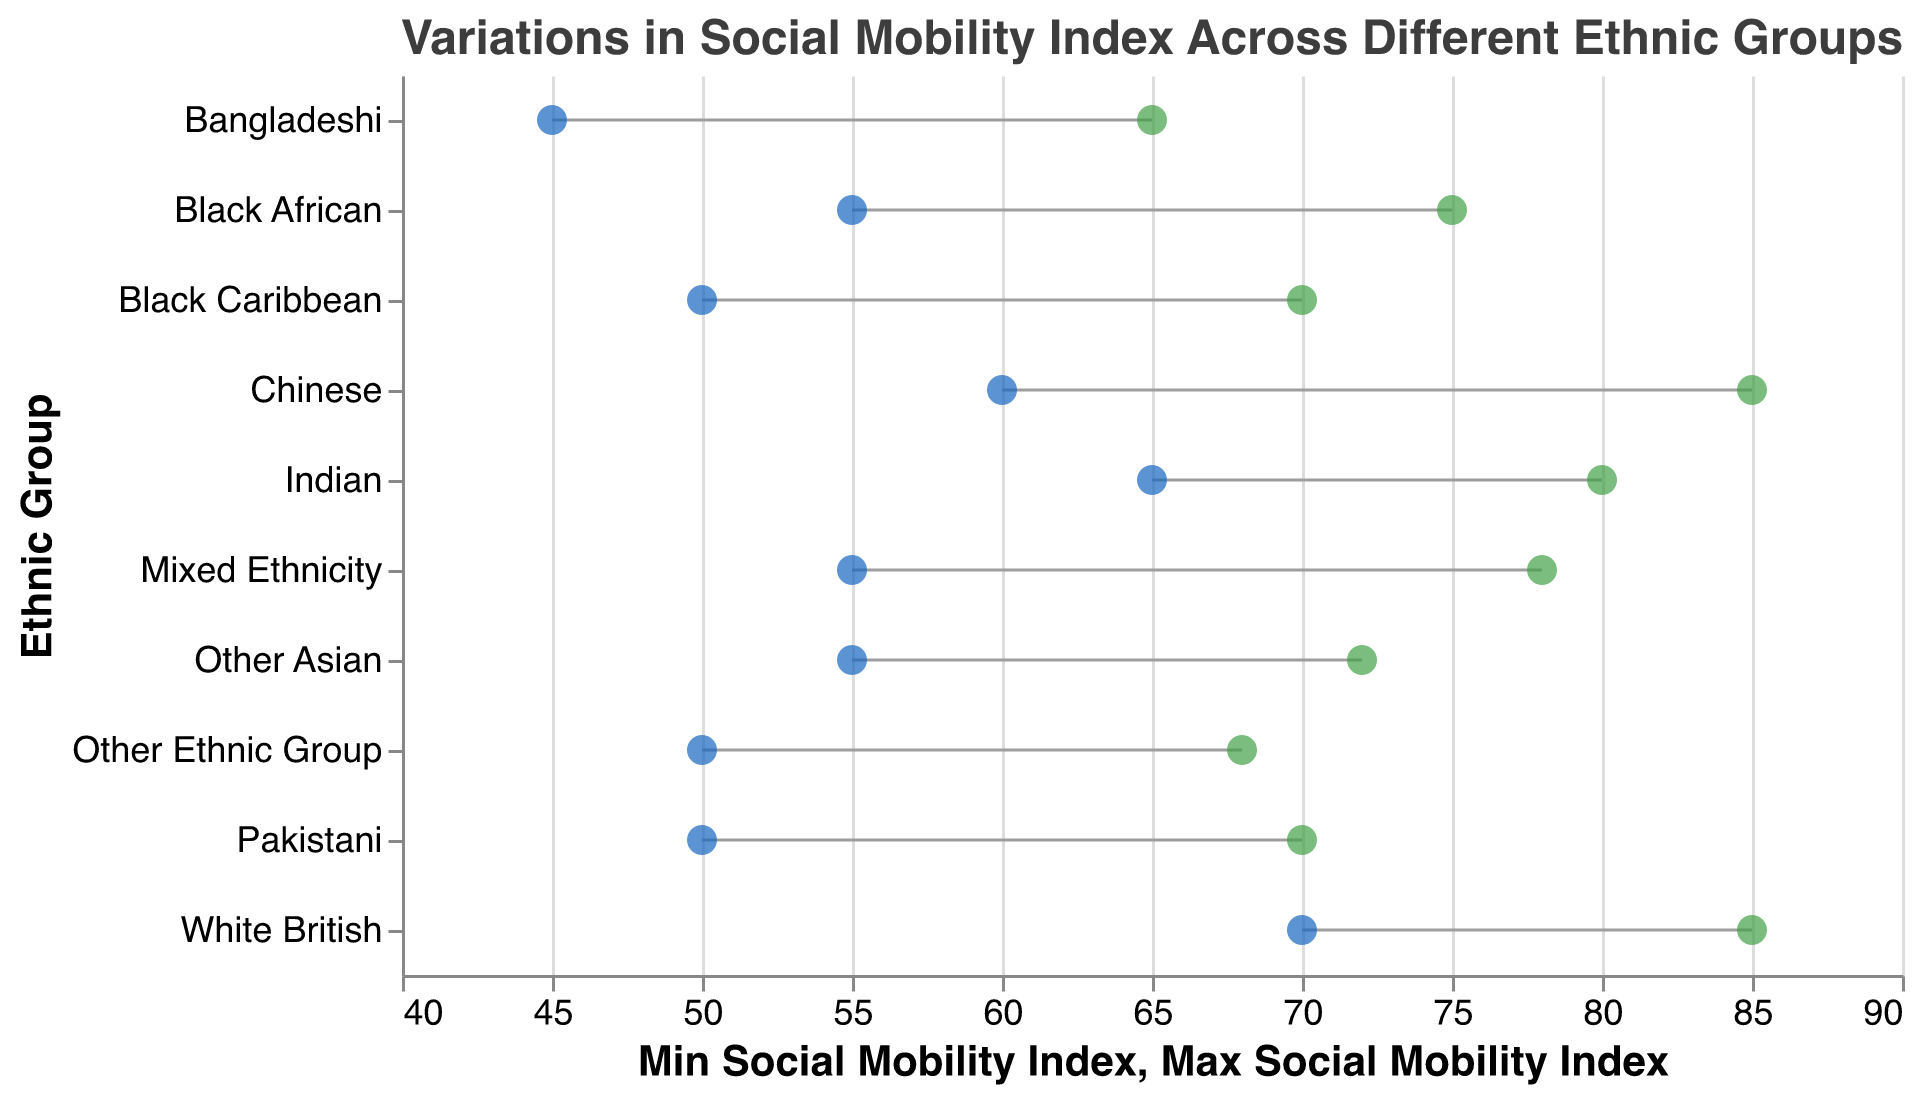What is the title of the figure? The title is written at the top of the figure. It reads, "Variations in Social Mobility Index Across Different Ethnic Groups."
Answer: Variations in Social Mobility Index Across Different Ethnic Groups Which ethnic group has the widest range in the Social Mobility Index? The group with the widest range has the largest difference between the maximum and minimum values. The Chinese and White British groups both range from 60 to 85 and 70 to 85, respectively (both 25 units).
Answer: Chinese, White British What is the minimum Social Mobility Index value for the Bangladeshi group? The minimum value is found on the left end of the range for the Bangladeshi group. It is 45.
Answer: 45 Which ethnic group has the smallest range in the Social Mobility Index? The group with the smallest range has the smallest difference between the maximum and minimum values. The 'Other Ethnic Group' ranges from 50 to 68, a difference of 18 units.
Answer: Other Ethnic Group How do the social mobility indices of the Indian and Pakistani groups compare? To compare, look at the ranges:
- Indian: 65 to 80
- Pakistani: 50 to 70
The Indian group's range is higher.
Answer: Indian group has higher indices What is the difference between the maximum Social Mobility Index of the Black African and Black Caribbean groups? The maximum value for Black African is 75, and for Black Caribbean, it is 70. So, the difference is 75 - 70.
Answer: 5 Which ethnic group has both high and low values within the range of 55 to 75? Check which group’s range intersects with both 55 and 75:
- Black African: 55 to 75 matches both ends.
- Mixed Ethnicity: 55 to 78 matches the low end.
- Other Asian: 55 to 72 matches the low end.
Only Black African fits both.
Answer: Black African Which group has the highest minimum Social Mobility Index? The highest minimum value among all groups is 70, which belongs to the White British group.
Answer: White British What is the median of the maximum Social Mobility Index values across all groups? List the maximum values: 85, 80, 70, 65, 75, 70, 85, 78, 72, 68. Arranged: 65, 68, 70, 70, 72, 75, 78, 80, 85, 85. Median of 10 numbers is the average of the 5th and 6th: (72+75)/2.
Answer: 73.5 